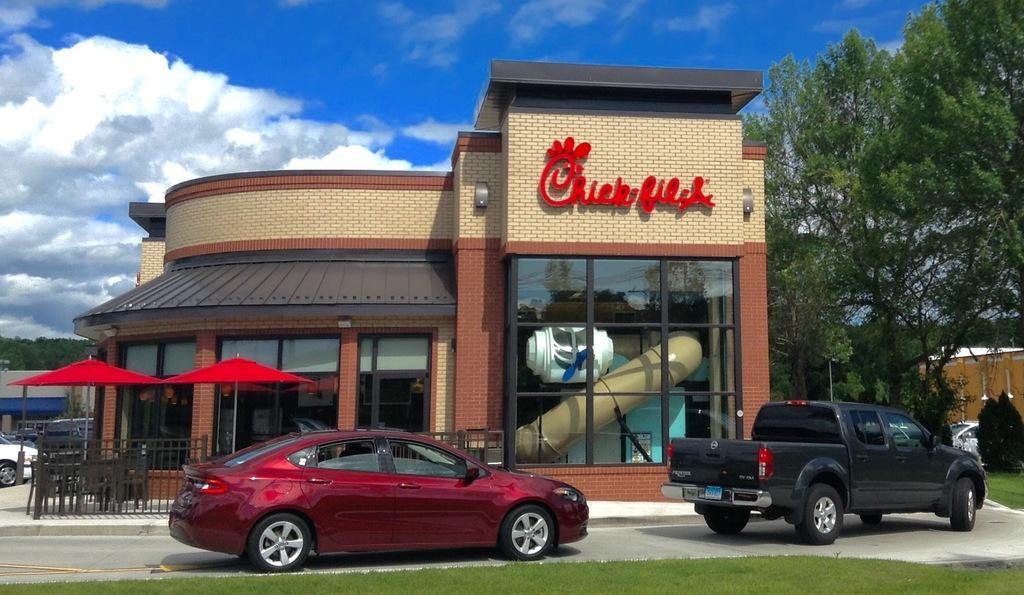Please provide a concise description of this image. In this image we can see vehicles. Also there are buildings with glass walls. On the building there is a name. There are umbrellas with poles. Also there are chairs and railing. In the background there are trees. And there is sky with clouds. 